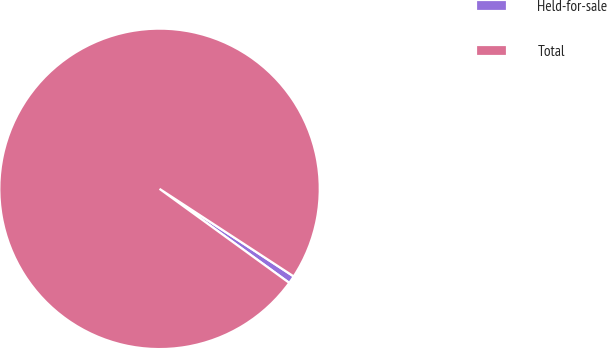Convert chart to OTSL. <chart><loc_0><loc_0><loc_500><loc_500><pie_chart><fcel>Held-for-sale<fcel>Total<nl><fcel>0.78%<fcel>99.22%<nl></chart> 